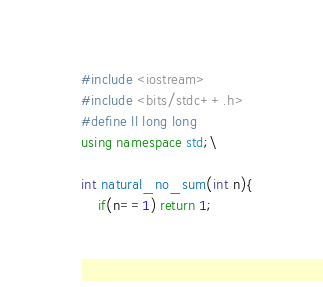Convert code to text. <code><loc_0><loc_0><loc_500><loc_500><_C++_>#include <iostream>
#include <bits/stdc++.h>
#define ll long long
using namespace std;\

int natural_no_sum(int n){
    if(n==1) return 1;</code> 